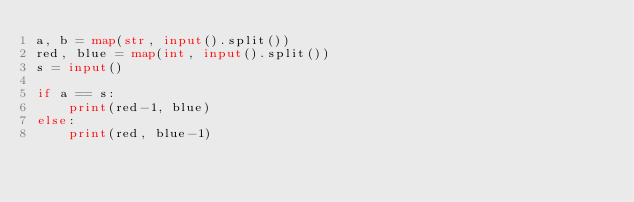<code> <loc_0><loc_0><loc_500><loc_500><_Python_>a, b = map(str, input().split())
red, blue = map(int, input().split())
s = input()

if a == s:
    print(red-1, blue)
else:
    print(red, blue-1)</code> 